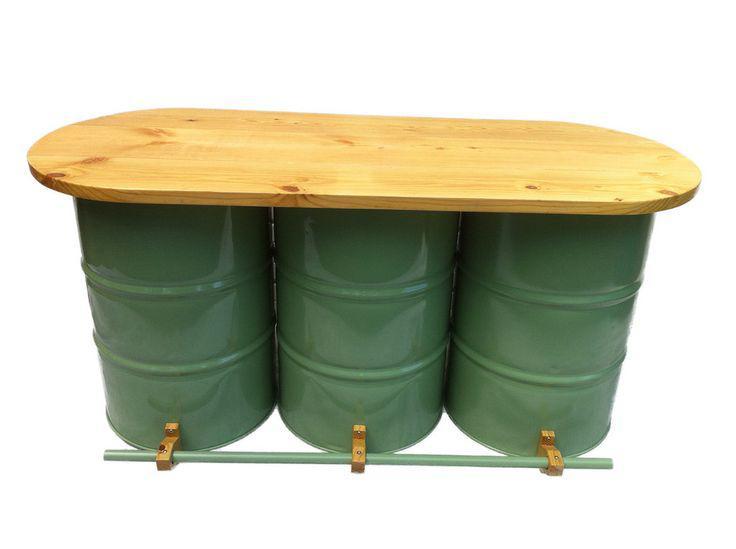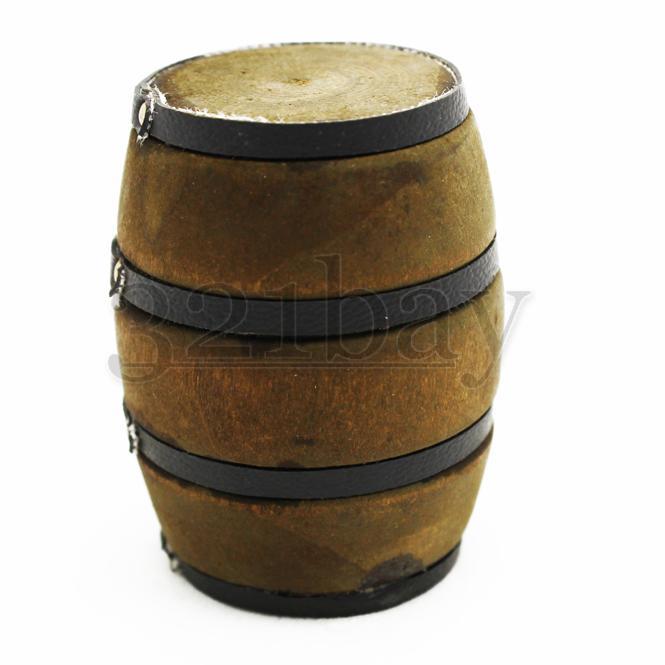The first image is the image on the left, the second image is the image on the right. Analyze the images presented: Is the assertion "There is a total of three green barrell with a wooden table top." valid? Answer yes or no. Yes. The first image is the image on the left, the second image is the image on the right. Examine the images to the left and right. Is the description "There are three green drums, with a wooden table running across the top of the drums." accurate? Answer yes or no. Yes. 